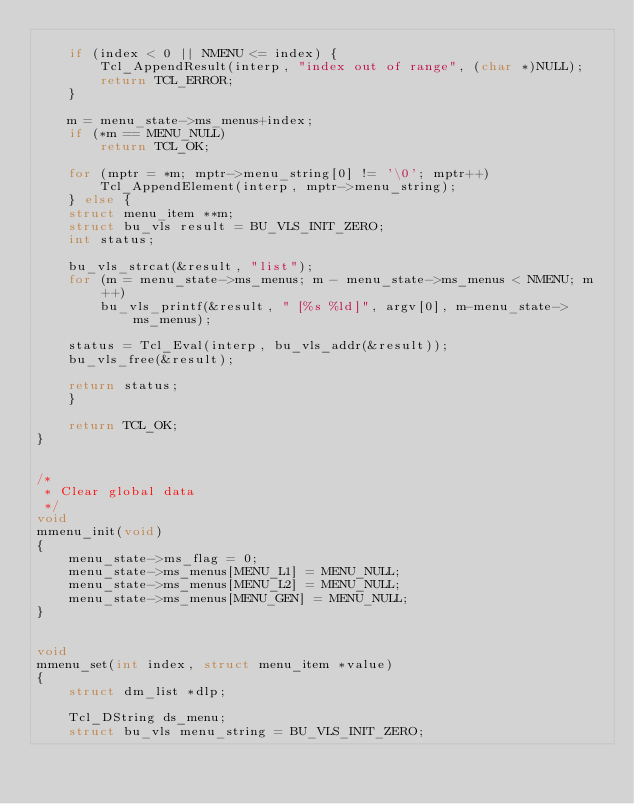<code> <loc_0><loc_0><loc_500><loc_500><_C_>
	if (index < 0 || NMENU <= index) {
	    Tcl_AppendResult(interp, "index out of range", (char *)NULL);
	    return TCL_ERROR;
	}

	m = menu_state->ms_menus+index;
	if (*m == MENU_NULL)
	    return TCL_OK;

	for (mptr = *m; mptr->menu_string[0] != '\0'; mptr++)
	    Tcl_AppendElement(interp, mptr->menu_string);
    } else {
	struct menu_item **m;
	struct bu_vls result = BU_VLS_INIT_ZERO;
	int status;

	bu_vls_strcat(&result, "list");
	for (m = menu_state->ms_menus; m - menu_state->ms_menus < NMENU; m++)
	    bu_vls_printf(&result, " [%s %ld]", argv[0], m-menu_state->ms_menus);

	status = Tcl_Eval(interp, bu_vls_addr(&result));
	bu_vls_free(&result);

	return status;
    }

    return TCL_OK;
}


/*
 * Clear global data
 */
void
mmenu_init(void)
{
    menu_state->ms_flag = 0;
    menu_state->ms_menus[MENU_L1] = MENU_NULL;
    menu_state->ms_menus[MENU_L2] = MENU_NULL;
    menu_state->ms_menus[MENU_GEN] = MENU_NULL;
}


void
mmenu_set(int index, struct menu_item *value)
{
    struct dm_list *dlp;

    Tcl_DString ds_menu;
    struct bu_vls menu_string = BU_VLS_INIT_ZERO;
</code> 